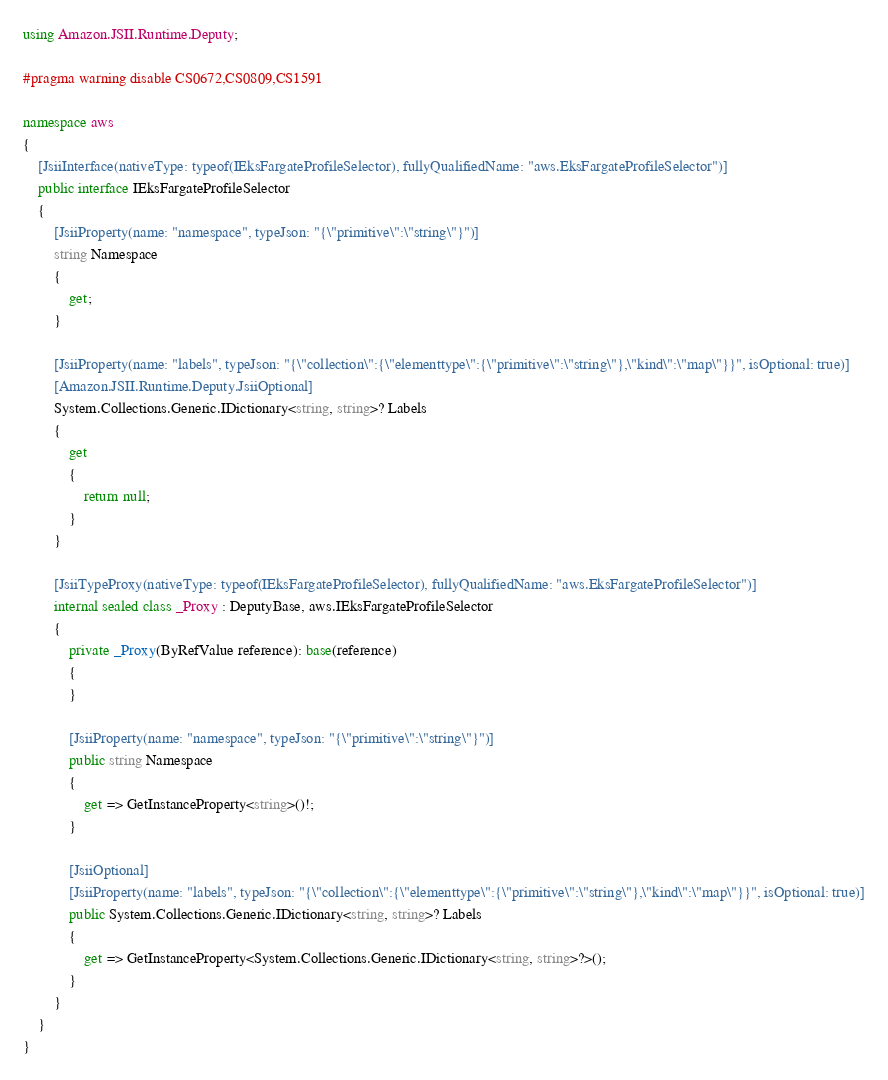Convert code to text. <code><loc_0><loc_0><loc_500><loc_500><_C#_>using Amazon.JSII.Runtime.Deputy;

#pragma warning disable CS0672,CS0809,CS1591

namespace aws
{
    [JsiiInterface(nativeType: typeof(IEksFargateProfileSelector), fullyQualifiedName: "aws.EksFargateProfileSelector")]
    public interface IEksFargateProfileSelector
    {
        [JsiiProperty(name: "namespace", typeJson: "{\"primitive\":\"string\"}")]
        string Namespace
        {
            get;
        }

        [JsiiProperty(name: "labels", typeJson: "{\"collection\":{\"elementtype\":{\"primitive\":\"string\"},\"kind\":\"map\"}}", isOptional: true)]
        [Amazon.JSII.Runtime.Deputy.JsiiOptional]
        System.Collections.Generic.IDictionary<string, string>? Labels
        {
            get
            {
                return null;
            }
        }

        [JsiiTypeProxy(nativeType: typeof(IEksFargateProfileSelector), fullyQualifiedName: "aws.EksFargateProfileSelector")]
        internal sealed class _Proxy : DeputyBase, aws.IEksFargateProfileSelector
        {
            private _Proxy(ByRefValue reference): base(reference)
            {
            }

            [JsiiProperty(name: "namespace", typeJson: "{\"primitive\":\"string\"}")]
            public string Namespace
            {
                get => GetInstanceProperty<string>()!;
            }

            [JsiiOptional]
            [JsiiProperty(name: "labels", typeJson: "{\"collection\":{\"elementtype\":{\"primitive\":\"string\"},\"kind\":\"map\"}}", isOptional: true)]
            public System.Collections.Generic.IDictionary<string, string>? Labels
            {
                get => GetInstanceProperty<System.Collections.Generic.IDictionary<string, string>?>();
            }
        }
    }
}
</code> 